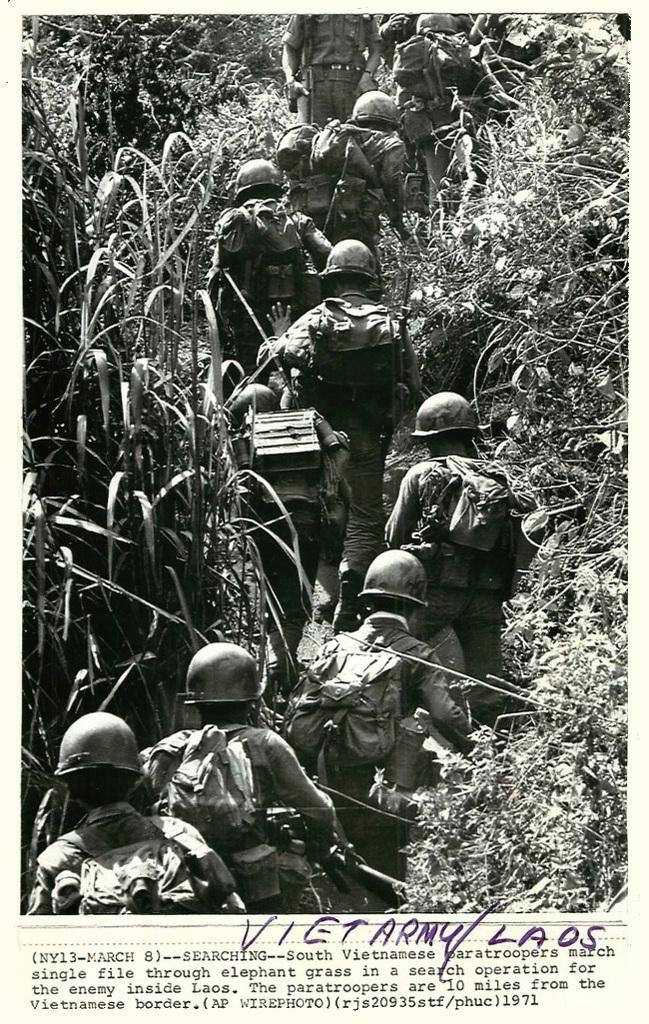What is the color scheme of the image? The image is black and white. How many people are present in the image? There are many people in the image. What are the people wearing on their heads? The people are wearing helmets. What are the people carrying in their hands? The people are carrying bags. What type of vegetation can be seen on the sides of the image? There are plants on the sides of the image. What is written at the bottom of the image? There is text at the bottom of the image. What type of skin condition can be seen on the people in the image? There is no indication of any skin condition on the people in the image, as it is a black and white image. What type of experience are the people having in the image? The image does not provide any information about the people's experience; it only shows them wearing helmets and carrying bags. What type of vegetable is being grown in the image? There is no vegetable being grown in the image; it only shows plants on the sides. 